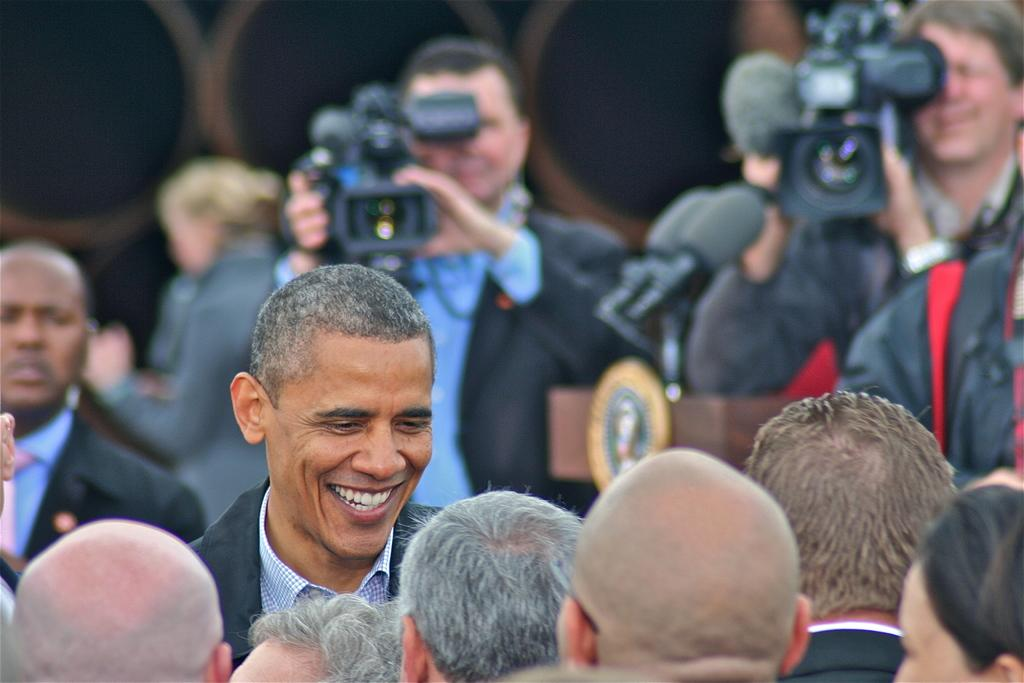Who is the main subject in the image? There is a man in the middle of the image. What is the man doing in the image? The man is talking to people in front of him. Can you describe the people in the background of the image? There are two persons in the background of the image, and they are taking a video with cameras. What type of fruit is being used as a prop by the man in the image? There is no fruit present in the image, and the man is not using any props. 